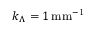<formula> <loc_0><loc_0><loc_500><loc_500>k _ { \Lambda } = 1 \, m m ^ { - 1 }</formula> 